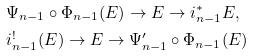<formula> <loc_0><loc_0><loc_500><loc_500>& \Psi _ { n - 1 } \circ \Phi _ { n - 1 } ( E ) \to E \to i _ { n - 1 } ^ { \ast } E , \\ & i _ { n - 1 } ^ { ! } ( E ) \to E \to \Psi _ { n - 1 } ^ { \prime } \circ \Phi _ { n - 1 } ( E )</formula> 